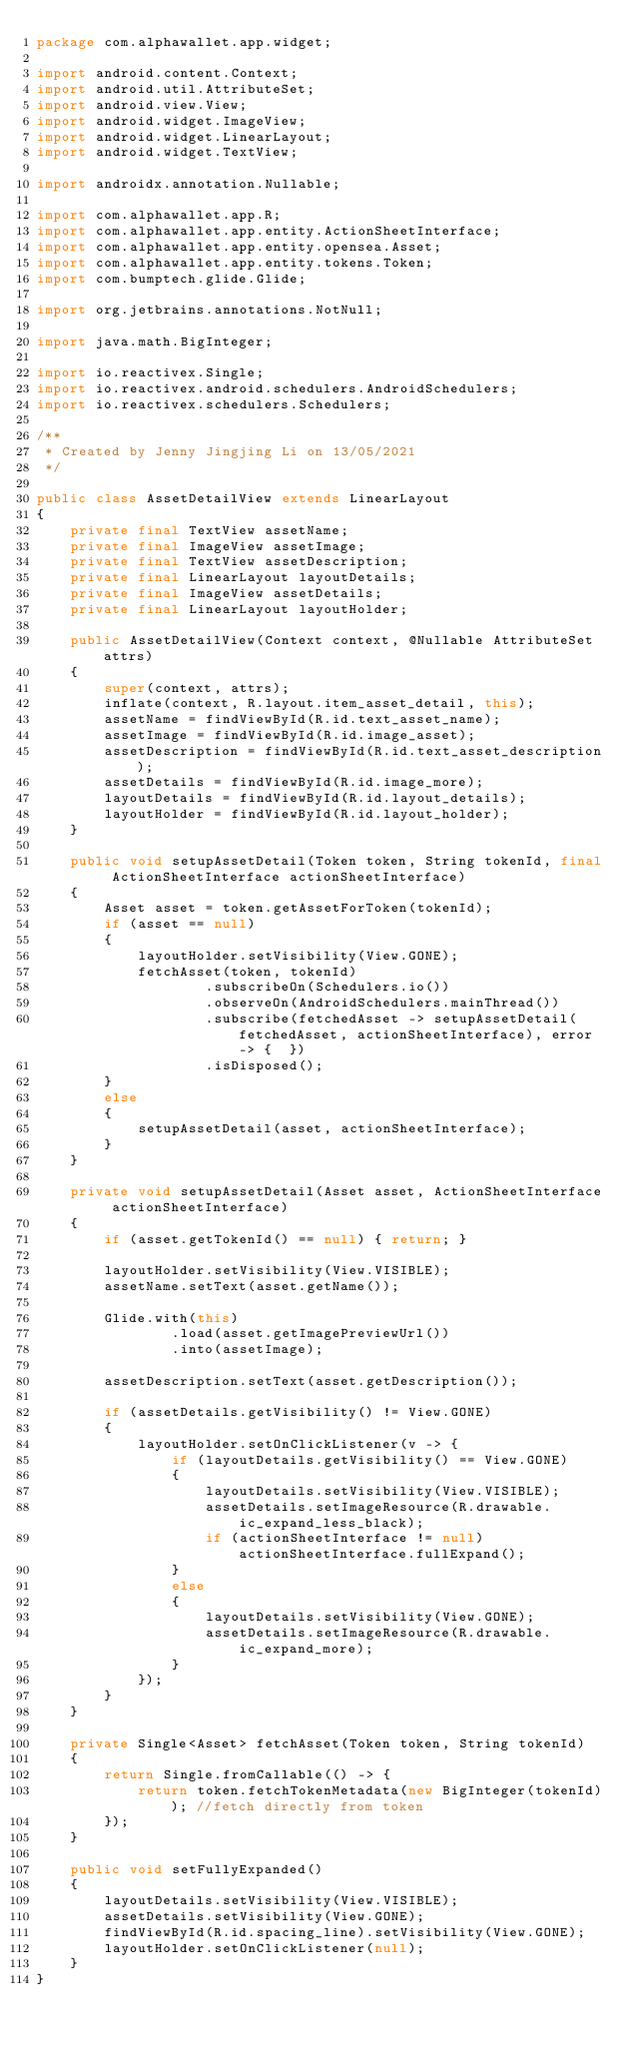<code> <loc_0><loc_0><loc_500><loc_500><_Java_>package com.alphawallet.app.widget;

import android.content.Context;
import android.util.AttributeSet;
import android.view.View;
import android.widget.ImageView;
import android.widget.LinearLayout;
import android.widget.TextView;

import androidx.annotation.Nullable;

import com.alphawallet.app.R;
import com.alphawallet.app.entity.ActionSheetInterface;
import com.alphawallet.app.entity.opensea.Asset;
import com.alphawallet.app.entity.tokens.Token;
import com.bumptech.glide.Glide;

import org.jetbrains.annotations.NotNull;

import java.math.BigInteger;

import io.reactivex.Single;
import io.reactivex.android.schedulers.AndroidSchedulers;
import io.reactivex.schedulers.Schedulers;

/**
 * Created by Jenny Jingjing Li on 13/05/2021
 */

public class AssetDetailView extends LinearLayout
{
    private final TextView assetName;
    private final ImageView assetImage;
    private final TextView assetDescription;
    private final LinearLayout layoutDetails;
    private final ImageView assetDetails;
    private final LinearLayout layoutHolder;

    public AssetDetailView(Context context, @Nullable AttributeSet attrs)
    {
        super(context, attrs);
        inflate(context, R.layout.item_asset_detail, this);
        assetName = findViewById(R.id.text_asset_name);
        assetImage = findViewById(R.id.image_asset);
        assetDescription = findViewById(R.id.text_asset_description);
        assetDetails = findViewById(R.id.image_more);
        layoutDetails = findViewById(R.id.layout_details);
        layoutHolder = findViewById(R.id.layout_holder);
    }

    public void setupAssetDetail(Token token, String tokenId, final ActionSheetInterface actionSheetInterface)
    {
        Asset asset = token.getAssetForToken(tokenId);
        if (asset == null)
        {
            layoutHolder.setVisibility(View.GONE);
            fetchAsset(token, tokenId)
                    .subscribeOn(Schedulers.io())
                    .observeOn(AndroidSchedulers.mainThread())
                    .subscribe(fetchedAsset -> setupAssetDetail(fetchedAsset, actionSheetInterface), error -> {  })
                    .isDisposed();
        }
        else
        {
            setupAssetDetail(asset, actionSheetInterface);
        }
    }

    private void setupAssetDetail(Asset asset, ActionSheetInterface actionSheetInterface)
    {
        if (asset.getTokenId() == null) { return; }

        layoutHolder.setVisibility(View.VISIBLE);
        assetName.setText(asset.getName());

        Glide.with(this)
                .load(asset.getImagePreviewUrl())
                .into(assetImage);

        assetDescription.setText(asset.getDescription());

        if (assetDetails.getVisibility() != View.GONE)
        {
            layoutHolder.setOnClickListener(v -> {
                if (layoutDetails.getVisibility() == View.GONE)
                {
                    layoutDetails.setVisibility(View.VISIBLE);
                    assetDetails.setImageResource(R.drawable.ic_expand_less_black);
                    if (actionSheetInterface != null) actionSheetInterface.fullExpand();
                }
                else
                {
                    layoutDetails.setVisibility(View.GONE);
                    assetDetails.setImageResource(R.drawable.ic_expand_more);
                }
            });
        }
    }

    private Single<Asset> fetchAsset(Token token, String tokenId)
    {
        return Single.fromCallable(() -> {
            return token.fetchTokenMetadata(new BigInteger(tokenId)); //fetch directly from token
        });
    }

    public void setFullyExpanded()
    {
        layoutDetails.setVisibility(View.VISIBLE);
        assetDetails.setVisibility(View.GONE);
        findViewById(R.id.spacing_line).setVisibility(View.GONE);
        layoutHolder.setOnClickListener(null);
    }
}
</code> 